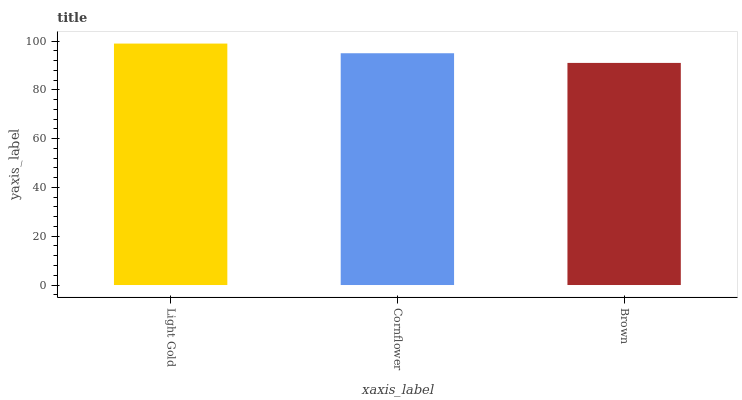Is Brown the minimum?
Answer yes or no. Yes. Is Light Gold the maximum?
Answer yes or no. Yes. Is Cornflower the minimum?
Answer yes or no. No. Is Cornflower the maximum?
Answer yes or no. No. Is Light Gold greater than Cornflower?
Answer yes or no. Yes. Is Cornflower less than Light Gold?
Answer yes or no. Yes. Is Cornflower greater than Light Gold?
Answer yes or no. No. Is Light Gold less than Cornflower?
Answer yes or no. No. Is Cornflower the high median?
Answer yes or no. Yes. Is Cornflower the low median?
Answer yes or no. Yes. Is Light Gold the high median?
Answer yes or no. No. Is Light Gold the low median?
Answer yes or no. No. 